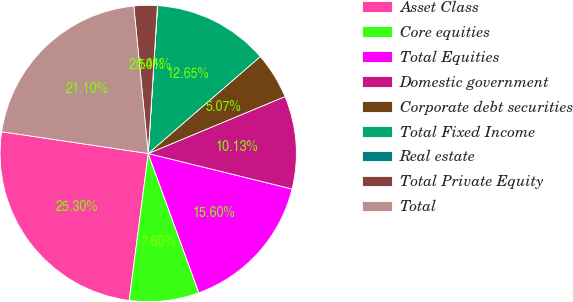Convert chart. <chart><loc_0><loc_0><loc_500><loc_500><pie_chart><fcel>Asset Class<fcel>Core equities<fcel>Total Equities<fcel>Domestic government<fcel>Corporate debt securities<fcel>Total Fixed Income<fcel>Real estate<fcel>Total Private Equity<fcel>Total<nl><fcel>25.3%<fcel>7.6%<fcel>15.6%<fcel>10.13%<fcel>5.07%<fcel>12.65%<fcel>0.01%<fcel>2.54%<fcel>21.1%<nl></chart> 